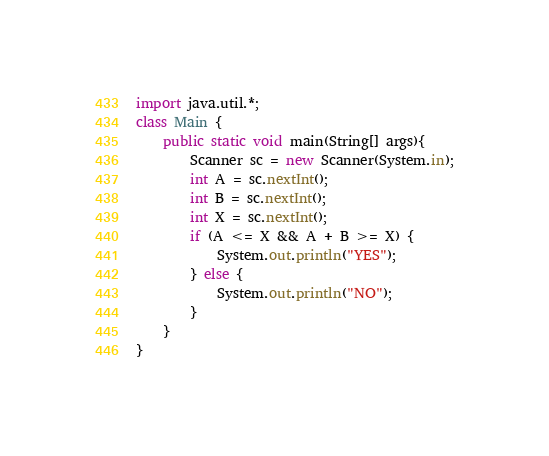Convert code to text. <code><loc_0><loc_0><loc_500><loc_500><_Java_>import java.util.*;
class Main {
	public static void main(String[] args){
		Scanner sc = new Scanner(System.in);
		int A = sc.nextInt();
		int B = sc.nextInt();
		int X = sc.nextInt();
		if (A <= X && A + B >= X) {
			System.out.println("YES");
		} else {
			System.out.println("NO");
		}
	}
}</code> 